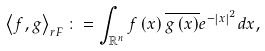<formula> <loc_0><loc_0><loc_500><loc_500>\left \langle f , g \right \rangle _ { r F } \colon = \int _ { \mathbb { R } ^ { n } } f \left ( x \right ) \overline { g \left ( x \right ) } e ^ { - \left | x \right | ^ { 2 } } d x ,</formula> 